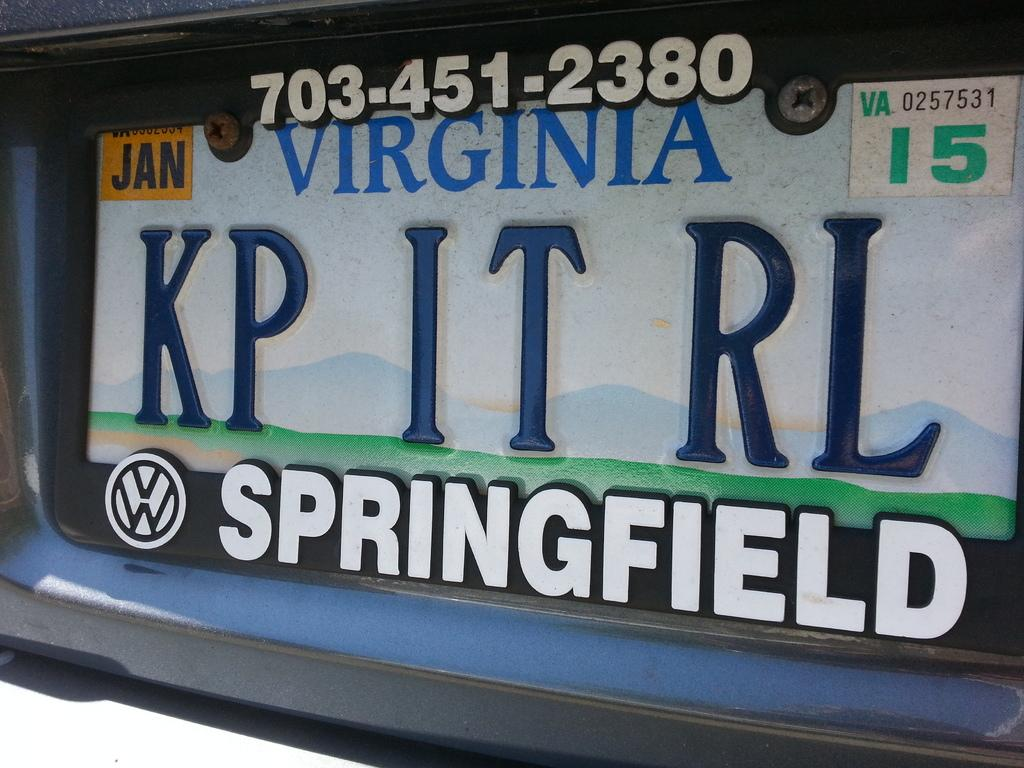<image>
Give a short and clear explanation of the subsequent image. the word Springfield on the back of a plate 